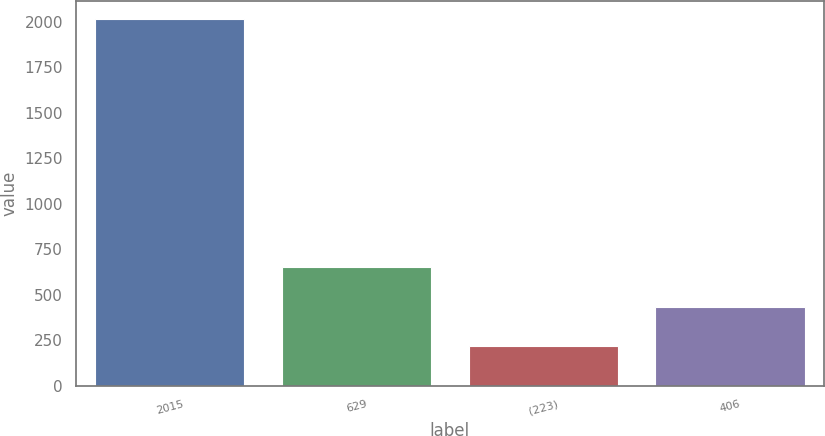Convert chart to OTSL. <chart><loc_0><loc_0><loc_500><loc_500><bar_chart><fcel>2015<fcel>629<fcel>(223)<fcel>406<nl><fcel>2013<fcel>650<fcel>220<fcel>430<nl></chart> 